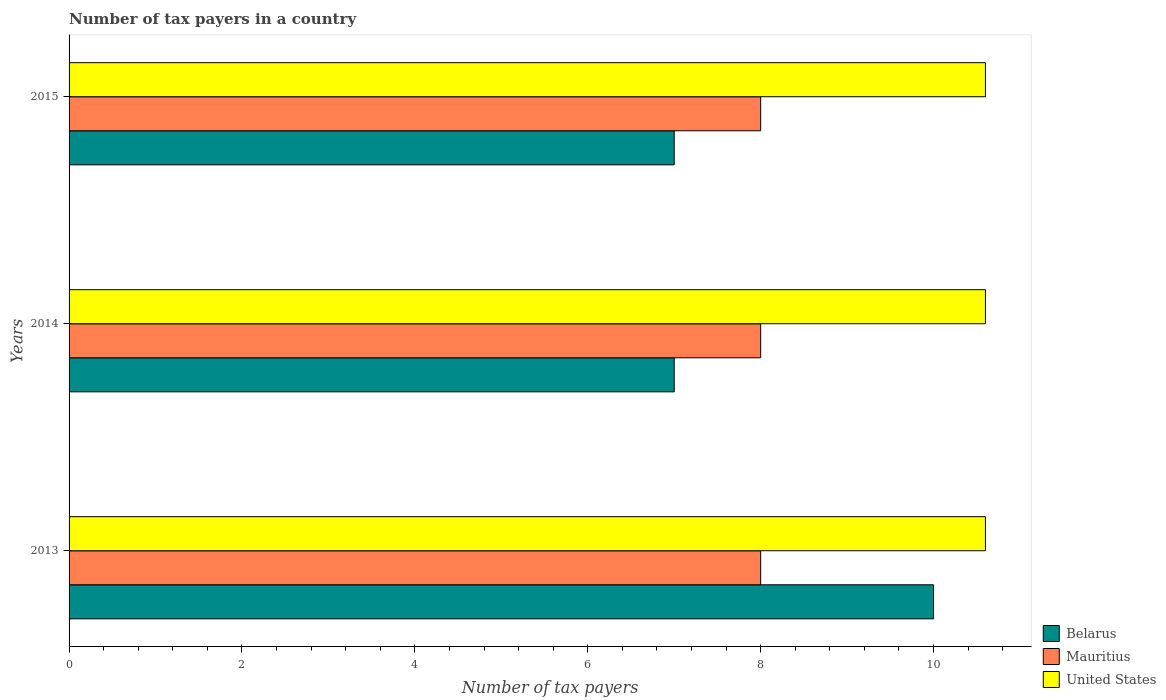How many groups of bars are there?
Provide a succinct answer. 3. Are the number of bars per tick equal to the number of legend labels?
Your response must be concise. Yes. Are the number of bars on each tick of the Y-axis equal?
Give a very brief answer. Yes. How many bars are there on the 3rd tick from the bottom?
Make the answer very short. 3. Across all years, what is the maximum number of tax payers in in United States?
Offer a very short reply. 10.6. Across all years, what is the minimum number of tax payers in in United States?
Provide a succinct answer. 10.6. In which year was the number of tax payers in in Belarus maximum?
Offer a very short reply. 2013. In which year was the number of tax payers in in Mauritius minimum?
Your response must be concise. 2013. What is the total number of tax payers in in United States in the graph?
Your answer should be compact. 31.8. What is the difference between the number of tax payers in in Belarus in 2013 and that in 2015?
Give a very brief answer. 3. What is the difference between the number of tax payers in in Mauritius in 2014 and the number of tax payers in in Belarus in 2015?
Make the answer very short. 1. What is the average number of tax payers in in United States per year?
Give a very brief answer. 10.6. In the year 2015, what is the difference between the number of tax payers in in Belarus and number of tax payers in in United States?
Your answer should be very brief. -3.6. In how many years, is the number of tax payers in in United States greater than 2.4 ?
Give a very brief answer. 3. What is the difference between the highest and the second highest number of tax payers in in Mauritius?
Your answer should be compact. 0. What is the difference between the highest and the lowest number of tax payers in in United States?
Ensure brevity in your answer.  0. In how many years, is the number of tax payers in in Belarus greater than the average number of tax payers in in Belarus taken over all years?
Keep it short and to the point. 1. What does the 2nd bar from the top in 2014 represents?
Provide a short and direct response. Mauritius. What does the 3rd bar from the bottom in 2014 represents?
Give a very brief answer. United States. Is it the case that in every year, the sum of the number of tax payers in in Mauritius and number of tax payers in in United States is greater than the number of tax payers in in Belarus?
Ensure brevity in your answer.  Yes. How many bars are there?
Offer a terse response. 9. Are all the bars in the graph horizontal?
Offer a terse response. Yes. What is the difference between two consecutive major ticks on the X-axis?
Offer a very short reply. 2. Are the values on the major ticks of X-axis written in scientific E-notation?
Offer a terse response. No. Does the graph contain any zero values?
Your answer should be compact. No. How are the legend labels stacked?
Provide a short and direct response. Vertical. What is the title of the graph?
Give a very brief answer. Number of tax payers in a country. Does "St. Vincent and the Grenadines" appear as one of the legend labels in the graph?
Your answer should be compact. No. What is the label or title of the X-axis?
Keep it short and to the point. Number of tax payers. What is the Number of tax payers in Belarus in 2014?
Offer a very short reply. 7. What is the Number of tax payers in United States in 2014?
Keep it short and to the point. 10.6. Across all years, what is the maximum Number of tax payers of Belarus?
Offer a very short reply. 10. Across all years, what is the maximum Number of tax payers in Mauritius?
Your answer should be compact. 8. Across all years, what is the minimum Number of tax payers in Belarus?
Ensure brevity in your answer.  7. Across all years, what is the minimum Number of tax payers in Mauritius?
Offer a very short reply. 8. Across all years, what is the minimum Number of tax payers of United States?
Provide a short and direct response. 10.6. What is the total Number of tax payers in Belarus in the graph?
Make the answer very short. 24. What is the total Number of tax payers in Mauritius in the graph?
Keep it short and to the point. 24. What is the total Number of tax payers of United States in the graph?
Provide a short and direct response. 31.8. What is the difference between the Number of tax payers of Belarus in 2013 and that in 2014?
Make the answer very short. 3. What is the difference between the Number of tax payers in Mauritius in 2013 and that in 2014?
Ensure brevity in your answer.  0. What is the difference between the Number of tax payers of Belarus in 2014 and that in 2015?
Make the answer very short. 0. What is the difference between the Number of tax payers in Mauritius in 2014 and that in 2015?
Ensure brevity in your answer.  0. What is the difference between the Number of tax payers in United States in 2014 and that in 2015?
Provide a succinct answer. 0. What is the difference between the Number of tax payers in Belarus in 2013 and the Number of tax payers in Mauritius in 2014?
Provide a short and direct response. 2. What is the difference between the Number of tax payers of Belarus in 2013 and the Number of tax payers of United States in 2014?
Provide a succinct answer. -0.6. What is the difference between the Number of tax payers of Mauritius in 2013 and the Number of tax payers of United States in 2014?
Your response must be concise. -2.6. What is the difference between the Number of tax payers in Belarus in 2013 and the Number of tax payers in Mauritius in 2015?
Offer a very short reply. 2. What is the difference between the Number of tax payers of Belarus in 2013 and the Number of tax payers of United States in 2015?
Your response must be concise. -0.6. What is the difference between the Number of tax payers of Mauritius in 2013 and the Number of tax payers of United States in 2015?
Provide a short and direct response. -2.6. What is the difference between the Number of tax payers in Belarus in 2014 and the Number of tax payers in United States in 2015?
Give a very brief answer. -3.6. What is the difference between the Number of tax payers in Mauritius in 2014 and the Number of tax payers in United States in 2015?
Make the answer very short. -2.6. What is the average Number of tax payers in Belarus per year?
Give a very brief answer. 8. In the year 2013, what is the difference between the Number of tax payers of Belarus and Number of tax payers of Mauritius?
Give a very brief answer. 2. In the year 2013, what is the difference between the Number of tax payers of Belarus and Number of tax payers of United States?
Provide a short and direct response. -0.6. In the year 2013, what is the difference between the Number of tax payers in Mauritius and Number of tax payers in United States?
Your response must be concise. -2.6. In the year 2014, what is the difference between the Number of tax payers of Belarus and Number of tax payers of United States?
Your response must be concise. -3.6. What is the ratio of the Number of tax payers of Belarus in 2013 to that in 2014?
Make the answer very short. 1.43. What is the ratio of the Number of tax payers in Belarus in 2013 to that in 2015?
Ensure brevity in your answer.  1.43. What is the ratio of the Number of tax payers of United States in 2013 to that in 2015?
Your answer should be compact. 1. What is the ratio of the Number of tax payers in Mauritius in 2014 to that in 2015?
Ensure brevity in your answer.  1. What is the difference between the highest and the second highest Number of tax payers in Mauritius?
Offer a terse response. 0. What is the difference between the highest and the second highest Number of tax payers of United States?
Make the answer very short. 0. 